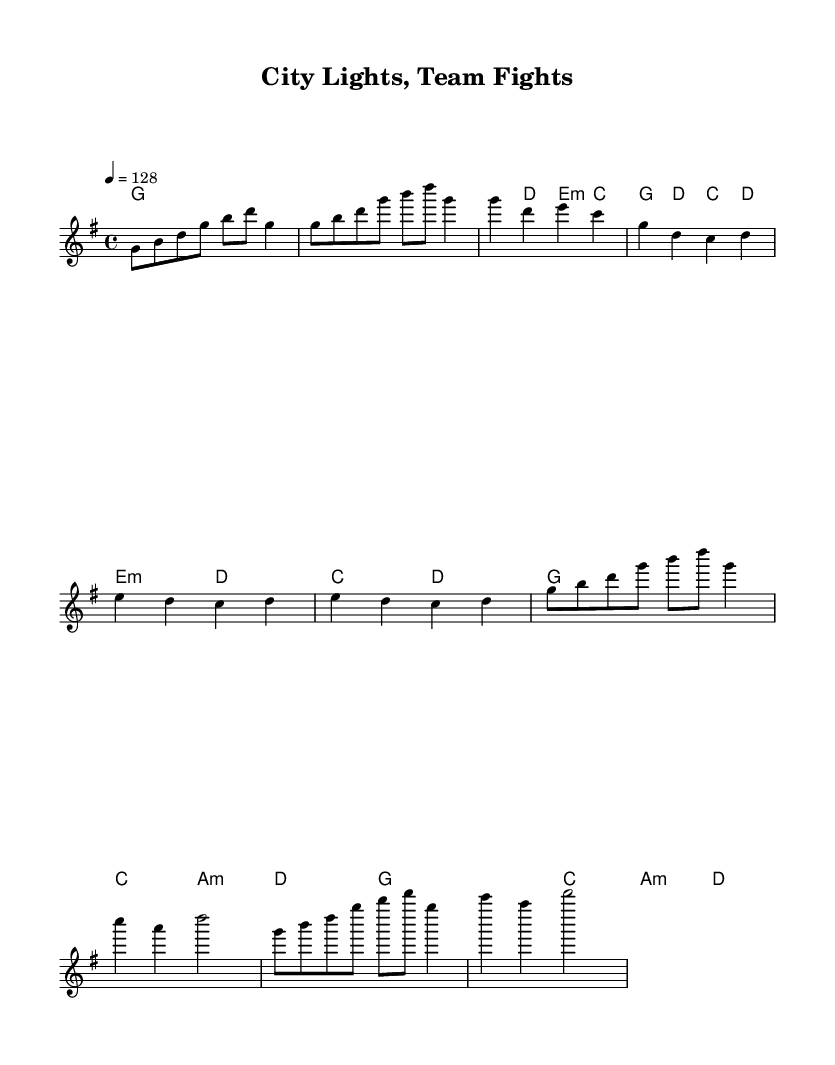What is the key signature of this music? The key signature is G major, which has one sharp (F#). This can be determined by looking at the key signature notation located at the beginning of the staff, which indicates the specific notes that are sharp in this key.
Answer: G major What is the time signature of this music? The time signature is 4/4, meaning there are four beats in each measure, and the quarter note gets one beat. This is indicated at the start of the sheet music, typically after the key signature, in a clear numerical format.
Answer: 4/4 What is the tempo marking for this piece? The tempo marking is 128 beats per minute, indicated by the term "4 = 128". This specifies how fast the music should be played and is generally placed at the beginning of the score.
Answer: 128 What is the structure of the music based on the sections? The structure consists of an Intro, Verse, Pre-Chorus, and Chorus. This can be identified by the labels and the layout of the music, showing the progression from one section to the next.
Answer: Intro, Verse, Pre-Chorus, Chorus How many chords are used in the verse section? The verse section uses four different chords: G, D, E minor, and C. Each chord is represented in the chord mode, and counting the unique chord symbols gives the total.
Answer: Four What does the rhythm of the chorus suggest about the mood? The chorus features a driving rhythm that is common in upbeat K-Pop tracks, indicating a high-energy atmosphere. In K-Pop, choruses often have strong, repetitive rhythms to engage listeners and create excitement.
Answer: High-energy How does the melody in the pre-chorus change compared to the verse? The melody in the pre-chorus features a descending pattern, creating tension before the chorus, while the verse has a more varied melodic contour. This distinction can be spotted by analyzing the notes and their progression between the sections.
Answer: Descending pattern 